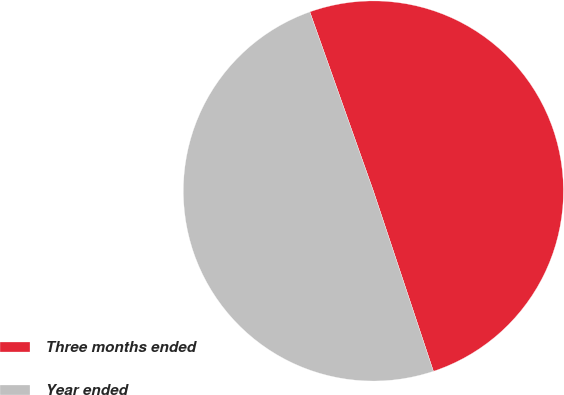<chart> <loc_0><loc_0><loc_500><loc_500><pie_chart><fcel>Three months ended<fcel>Year ended<nl><fcel>50.31%<fcel>49.69%<nl></chart> 